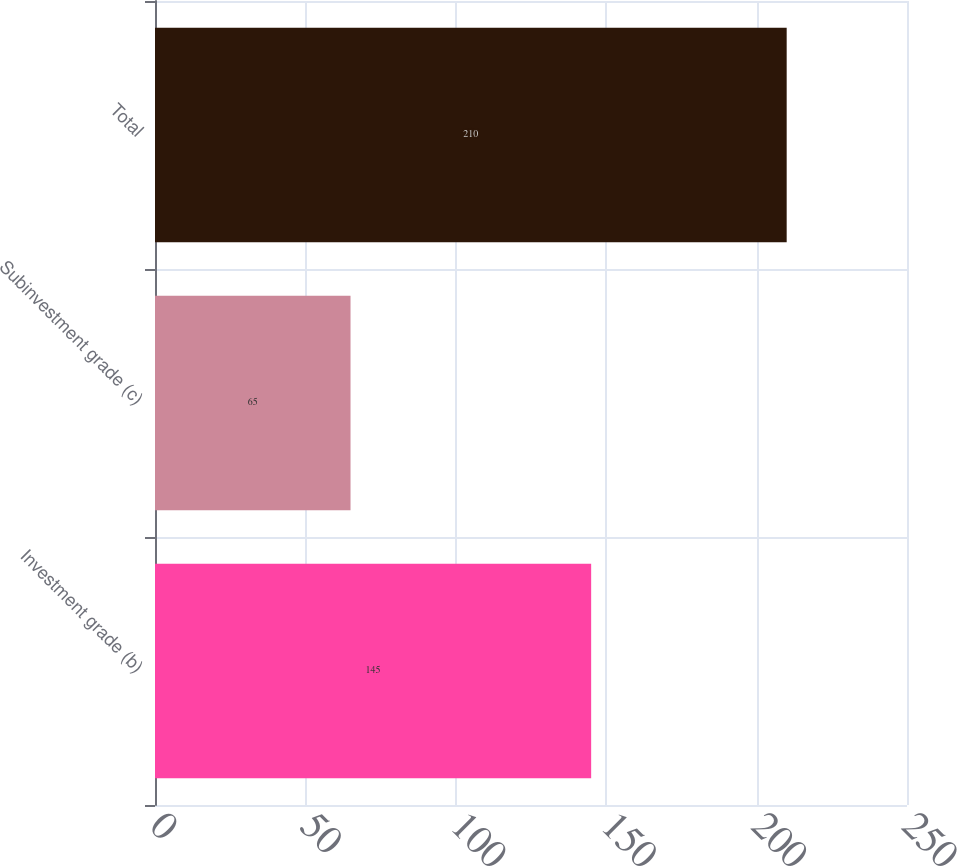Convert chart. <chart><loc_0><loc_0><loc_500><loc_500><bar_chart><fcel>Investment grade (b)<fcel>Subinvestment grade (c)<fcel>Total<nl><fcel>145<fcel>65<fcel>210<nl></chart> 